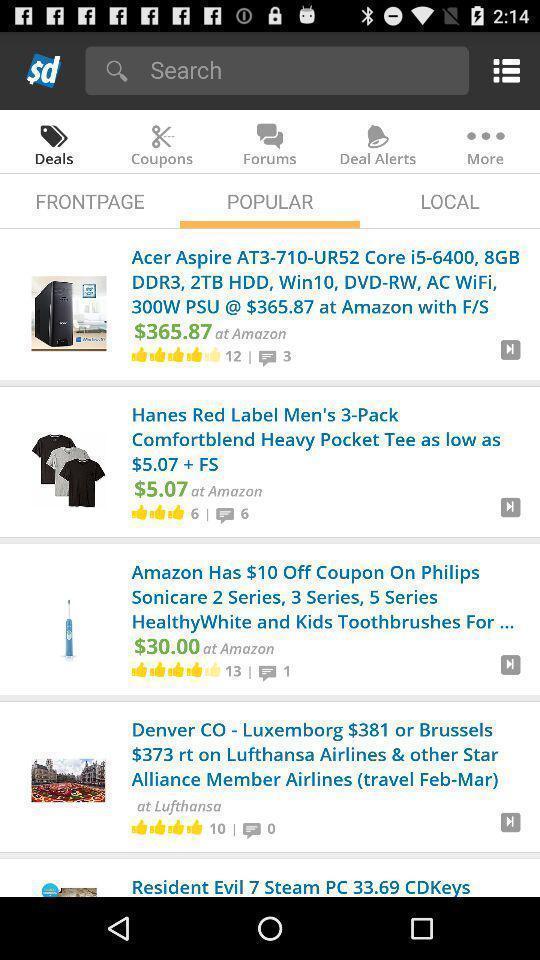Give me a narrative description of this picture. Screen shows popular options in a shopping app. 